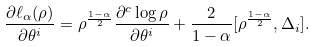<formula> <loc_0><loc_0><loc_500><loc_500>\frac { \partial \ell _ { \alpha } ( \rho ) } { \partial \theta ^ { i } } = \rho ^ { \frac { 1 - \alpha } { 2 } } \frac { \partial ^ { c } \log \rho } { \partial \theta ^ { i } } + \frac { 2 } { 1 - \alpha } [ \rho ^ { \frac { 1 - \alpha } { 2 } } , \Delta _ { i } ] .</formula> 